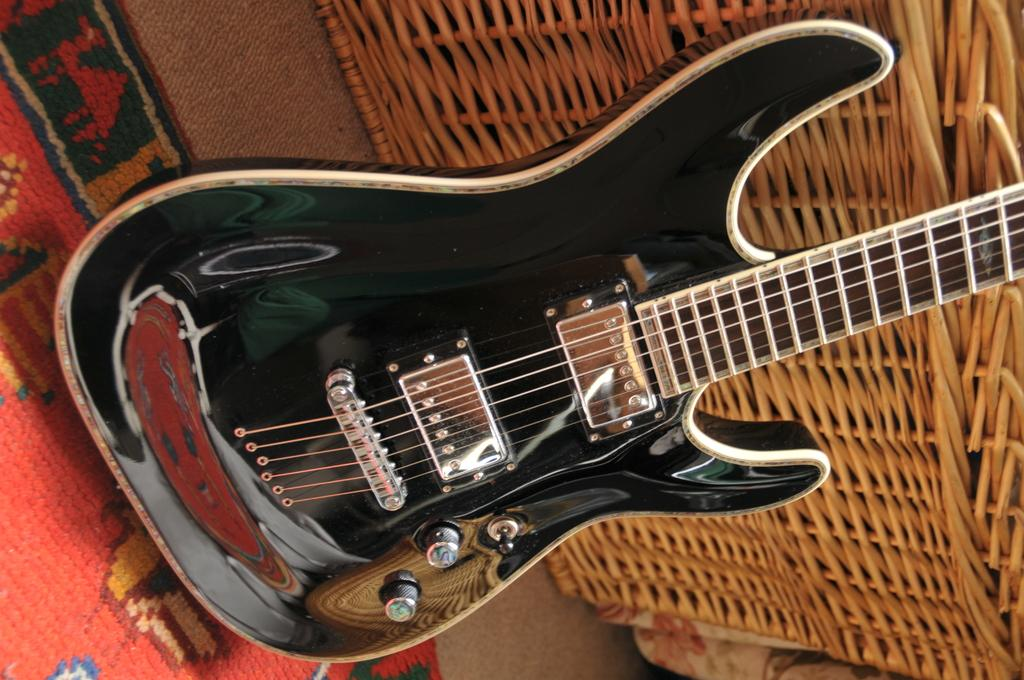What musical instrument is in the image? There is a guitar in the image. What is the guitar placed on? The guitar is on a mat. What else can be seen near the guitar? There are objects beside the guitar. What type of volleyball is being used as a stand for the guitar in the image? There is no volleyball present in the image, and the guitar is not being supported by a volleyball. 